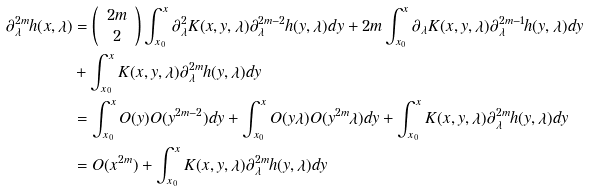<formula> <loc_0><loc_0><loc_500><loc_500>\partial _ { \lambda } ^ { 2 m } h ( x , \lambda ) & = \left ( \begin{array} { c } 2 m \\ 2 \end{array} \right ) \int _ { x _ { 0 } } ^ { x } \partial _ { \lambda } ^ { 2 } K ( x , y , \lambda ) \partial _ { \lambda } ^ { 2 m - 2 } h ( y , \lambda ) d y + 2 m \int _ { x _ { 0 } } ^ { x } \partial _ { \lambda } K ( x , y , \lambda ) \partial _ { \lambda } ^ { 2 m - 1 } h ( y , \lambda ) d y \\ & + \int _ { x _ { 0 } } ^ { x } K ( x , y , \lambda ) \partial _ { \lambda } ^ { 2 m } h ( y , \lambda ) d y \\ & = \int _ { x _ { 0 } } ^ { x } O ( y ) O ( y ^ { 2 m - 2 } ) d y + \int _ { x _ { 0 } } ^ { x } O ( y \lambda ) O ( y ^ { 2 m } \lambda ) d y + \int _ { x _ { 0 } } ^ { x } K ( x , y , \lambda ) \partial _ { \lambda } ^ { 2 m } h ( y , \lambda ) d y \\ & = O ( x ^ { 2 m } ) + \int _ { x _ { 0 } } ^ { x } K ( x , y , \lambda ) \partial _ { \lambda } ^ { 2 m } h ( y , \lambda ) d y</formula> 